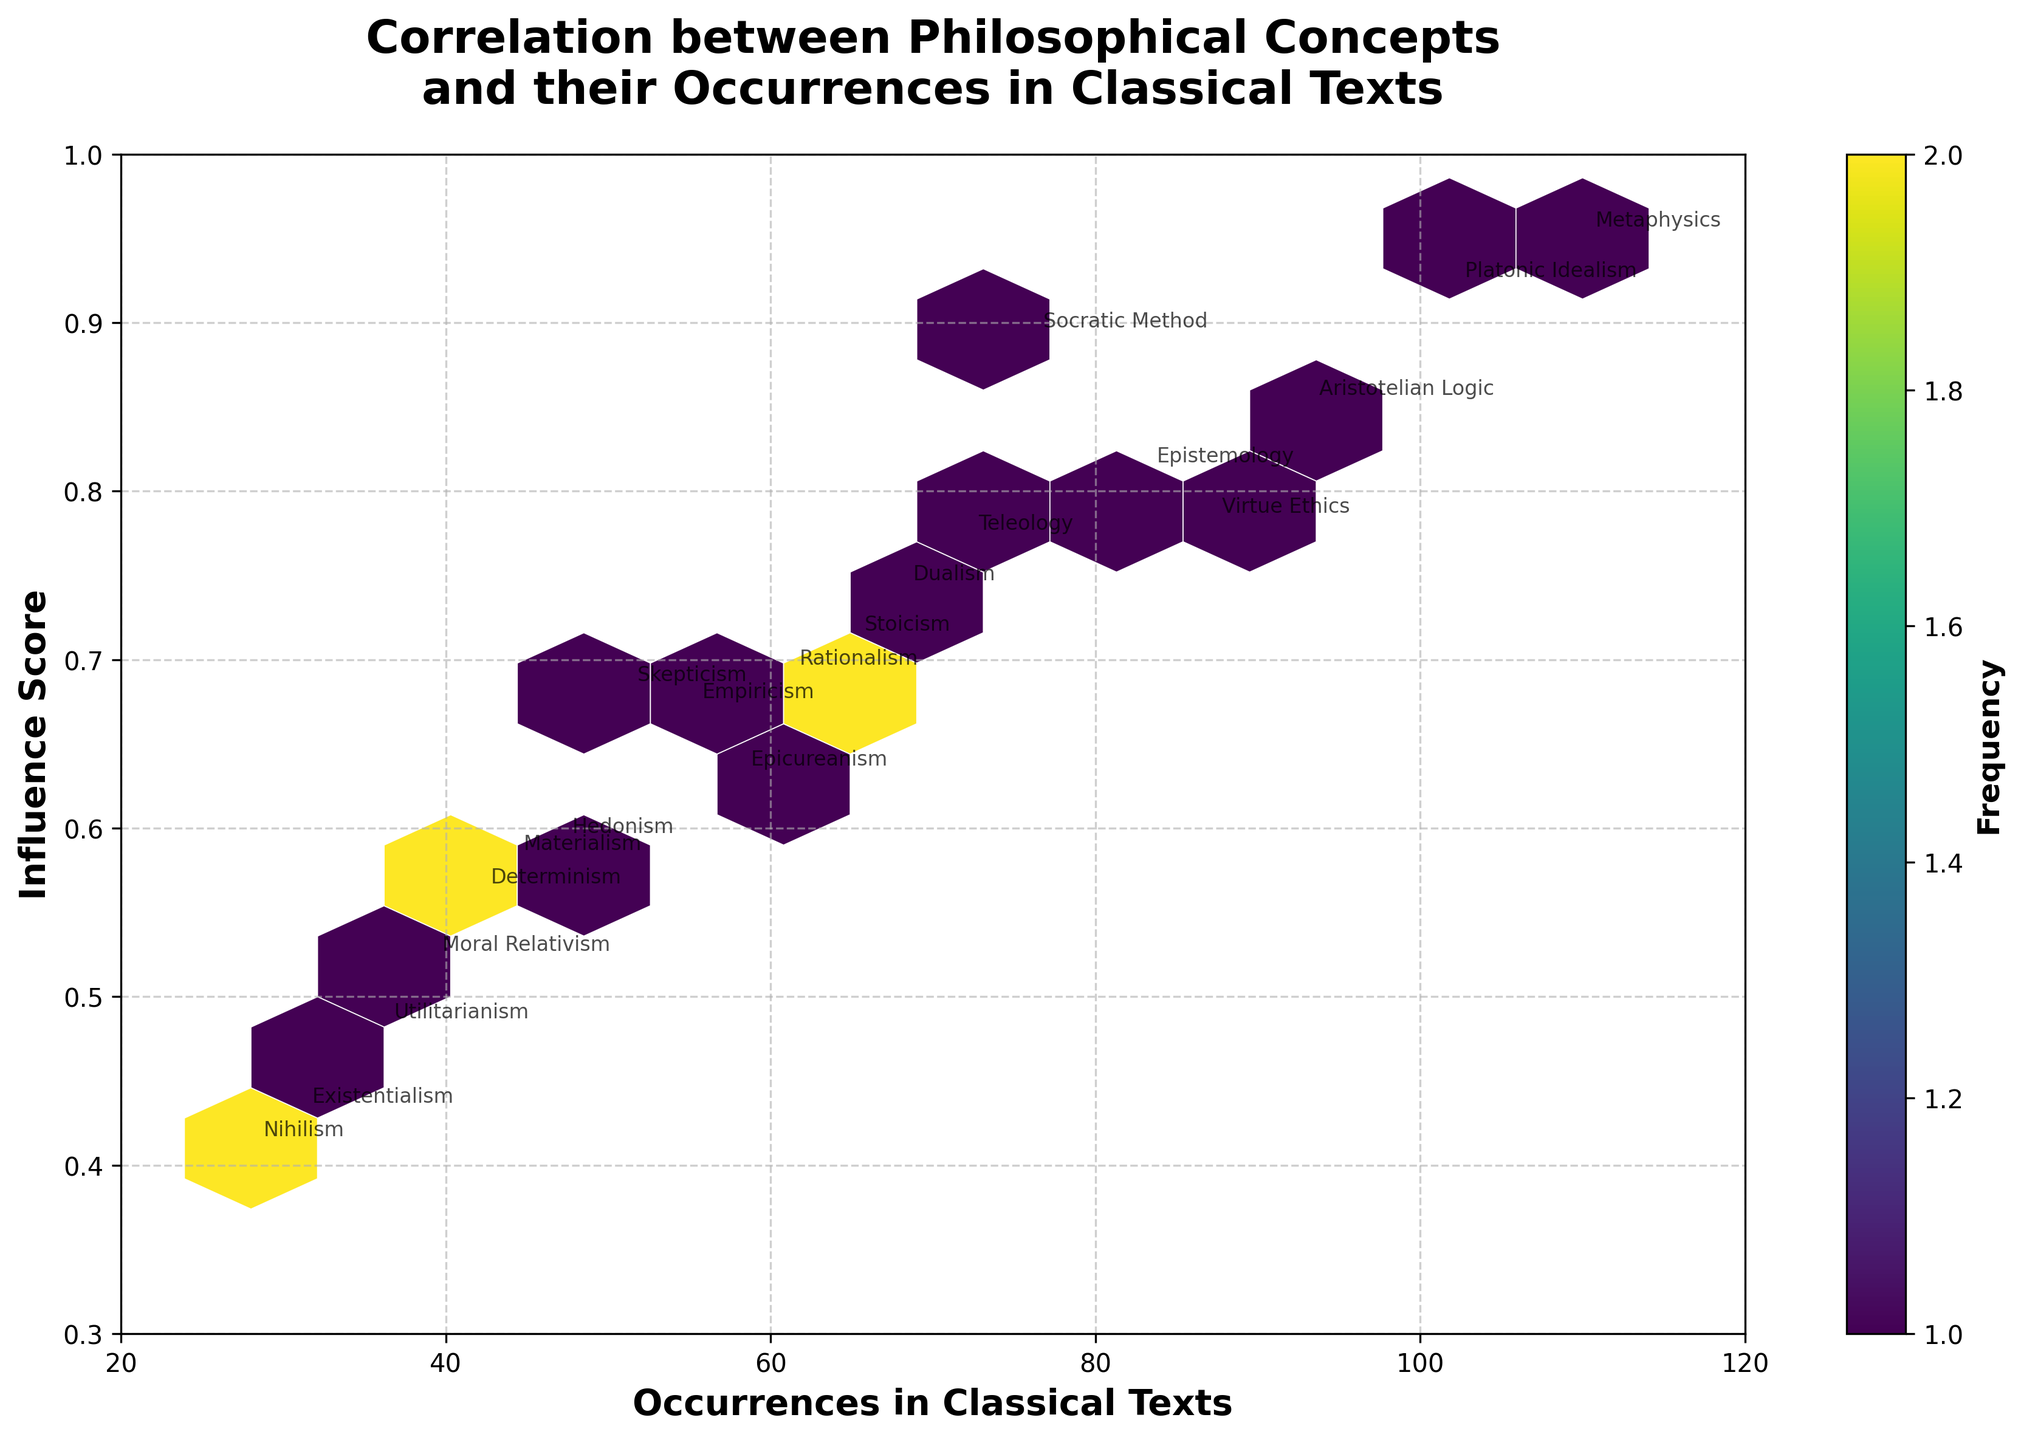What's the title of the plot? The title is displayed at the top of the plot in bold text.
Answer: Correlation between Philosophical Concepts and their Occurrences in Classical Texts What are the labels for the x-axis and y-axis? The labels are displayed along the axes in bold text. The x-axis shows the frequency of occurrences in classical texts, and the y-axis represents the influence score of the concepts.
Answer: Occurrences in Classical Texts, Influence Score How many data points are plotted in the hexbin plot? Each hexagon represents a cluster of data points. Given there are 20 philosophical concepts listed in the data, there are 20 data points represented in the plot.
Answer: 20 Which philosophical concept has the highest influence score and how often does it occur in classical texts? By looking at the annotations and the maximum y-axis value, we find the concept with the highest influence score. Metaphysics has the highest influence score, and its occurrence is indicated by the x-coordinate associated with its annotation.
Answer: Metaphysics, 110 occurrences What is the influence score range of the philosophical concepts depicted in the plot? By observing the y-axis, we can see that the influence scores range from the lowest to the highest value plotted. The y-axis ranges from 0.3 to 1.0.
Answer: 0.3 to 1.0 Which two concepts have the closest occurrence numbers in classical texts but show a noticeable difference in influence score? By comparing the annotations for occurrence numbers and then checking their influence scores, we can identify two concepts that fit the description. Aristotelian Logic (93) and Virtue Ethics (87) have close occurrence numbers but their influence scores differ noticeably.
Answer: Aristotelian Logic, Virtue Ethics What color represents higher frequencies of clustered data points in the hexbin plot? The color bar indicates how the frequency is represented by color intensity, with darker colors typically representing higher frequencies.
Answer: Darker colors Are there any concepts with both low text occurrences and low influence scores? Name one. By looking at the lower-left section of the plot both in terms of occurrences and influence scores, we can find such concepts.
Answer: Nihilism What is the general trend between occurrences in classical texts and influence scores? Observing the scatter of data points and their clustering, we can see if there's an upward, downward, or no trend. The points appear to show an upward trend, indicating that higher occurrences tend to have higher influence scores.
Answer: Upward trend Which concept lies closest to the center of the plot, and what does it represent in terms of occurrences and influence score? By identifying the midpoint range of both the x-axis and y-axis, we can find the concept closest to the center. Epistemology, with approximately 83 occurrences and an influence score of around 0.81, lies near the center.
Answer: Epistemology, 83 occurrences, 0.81 influence score 